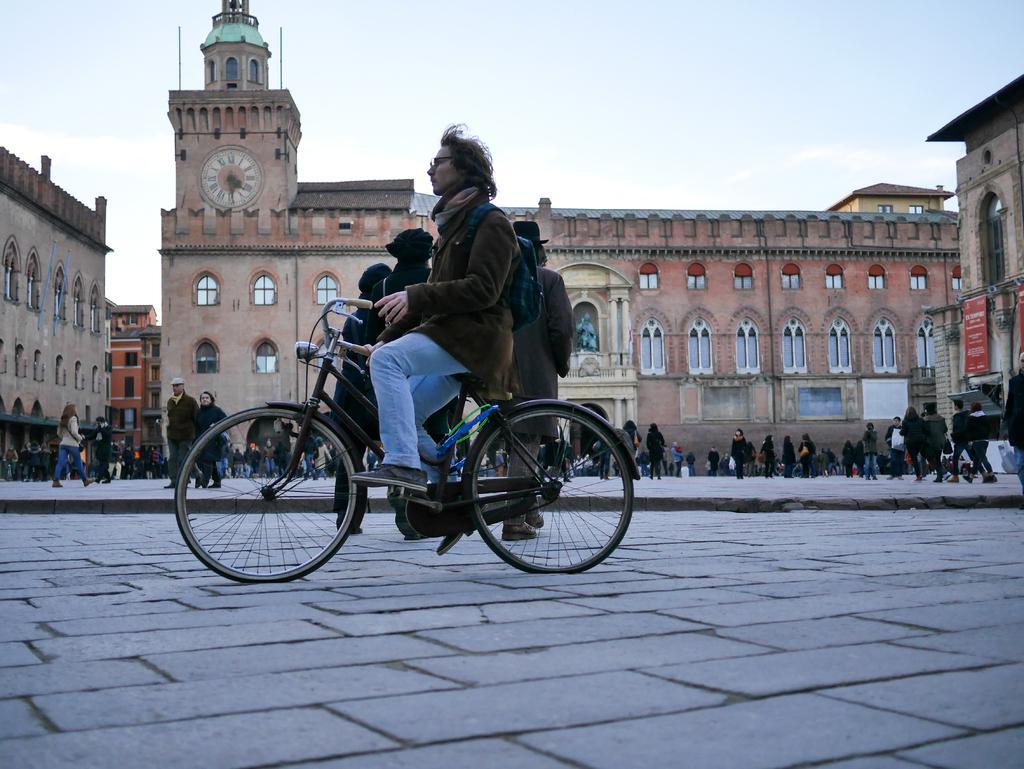Could you give a brief overview of what you see in this image? At the top we can see sky. This is a clock tower. These are buildings. Here we can see persons standing and walking near to the tower. We can see one man riding a bicycle. Near to him we can see persons standing 